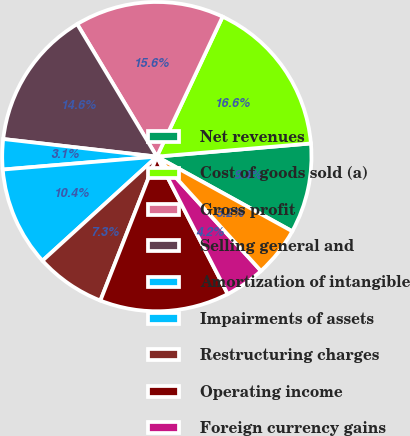Convert chart. <chart><loc_0><loc_0><loc_500><loc_500><pie_chart><fcel>Net revenues<fcel>Cost of goods sold (a)<fcel>Gross profit<fcel>Selling general and<fcel>Amortization of intangible<fcel>Impairments of assets<fcel>Restructuring charges<fcel>Operating income<fcel>Foreign currency gains<fcel>Interest expense<nl><fcel>9.38%<fcel>16.65%<fcel>15.61%<fcel>14.57%<fcel>3.15%<fcel>10.42%<fcel>7.3%<fcel>13.53%<fcel>4.18%<fcel>5.22%<nl></chart> 